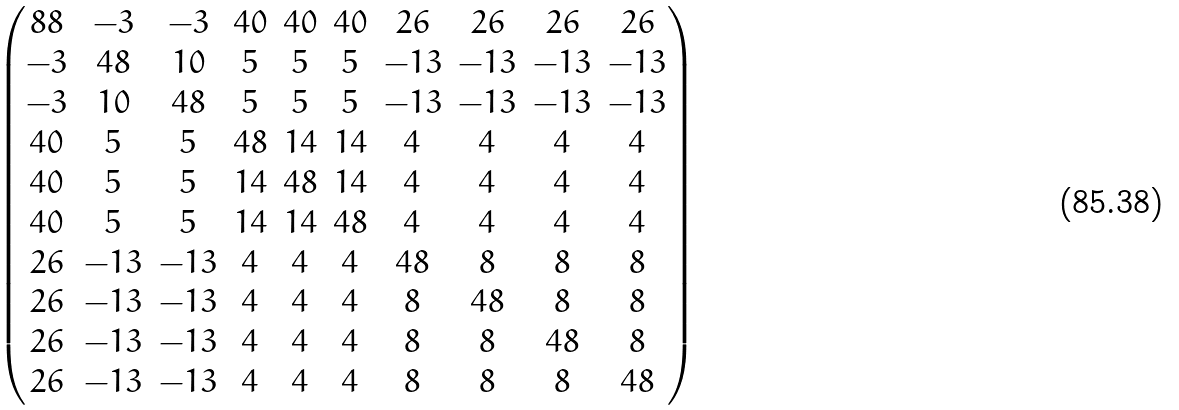<formula> <loc_0><loc_0><loc_500><loc_500>\begin{pmatrix} 8 8 & - 3 & - 3 & 4 0 & 4 0 & 4 0 & 2 6 & 2 6 & 2 6 & 2 6 \\ - 3 & 4 8 & 1 0 & 5 & 5 & 5 & - 1 3 & - 1 3 & - 1 3 & - 1 3 \\ - 3 & 1 0 & 4 8 & 5 & 5 & 5 & - 1 3 & - 1 3 & - 1 3 & - 1 3 \\ 4 0 & 5 & 5 & 4 8 & 1 4 & 1 4 & 4 & 4 & 4 & 4 \\ 4 0 & 5 & 5 & 1 4 & 4 8 & 1 4 & 4 & 4 & 4 & 4 \\ 4 0 & 5 & 5 & 1 4 & 1 4 & 4 8 & 4 & 4 & 4 & 4 \\ 2 6 & - 1 3 & - 1 3 & 4 & 4 & 4 & 4 8 & 8 & 8 & 8 \\ 2 6 & - 1 3 & - 1 3 & 4 & 4 & 4 & 8 & 4 8 & 8 & 8 \\ 2 6 & - 1 3 & - 1 3 & 4 & 4 & 4 & 8 & 8 & 4 8 & 8 \\ 2 6 & - 1 3 & - 1 3 & 4 & 4 & 4 & 8 & 8 & 8 & 4 8 \\ \end{pmatrix}</formula> 